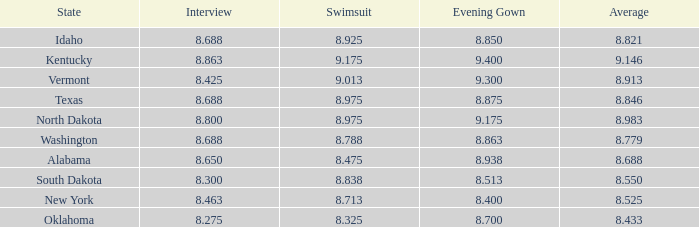846 has? None. 